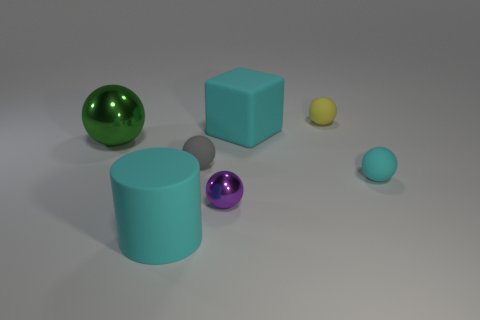Subtract 1 spheres. How many spheres are left? 4 Subtract all yellow matte spheres. How many spheres are left? 4 Subtract all blue balls. Subtract all red cylinders. How many balls are left? 5 Add 2 cyan matte cubes. How many objects exist? 9 Subtract all cylinders. How many objects are left? 6 Add 3 small cyan metal objects. How many small cyan metal objects exist? 3 Subtract 0 green cubes. How many objects are left? 7 Subtract all green metal cubes. Subtract all large green spheres. How many objects are left? 6 Add 3 yellow matte objects. How many yellow matte objects are left? 4 